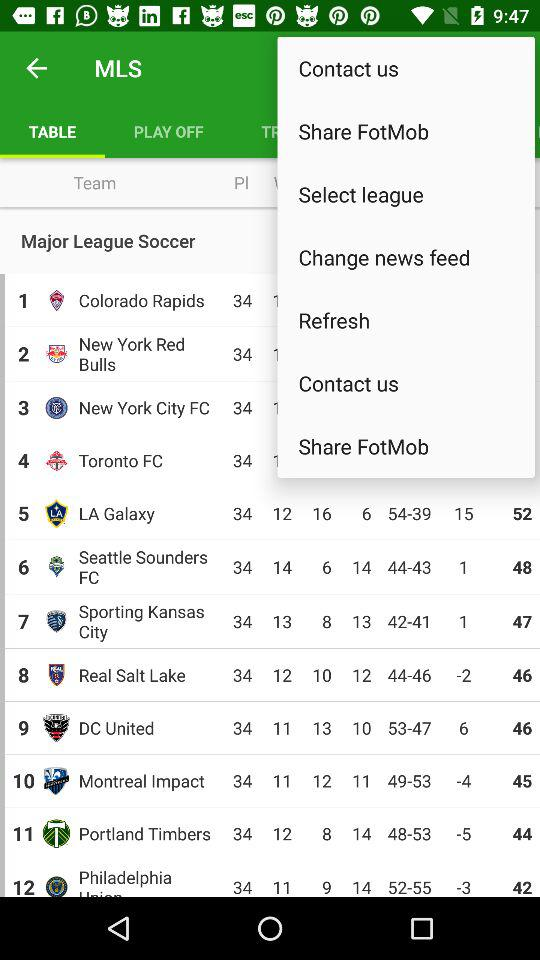Which tab is selected? The selected tab is "TABLE". 